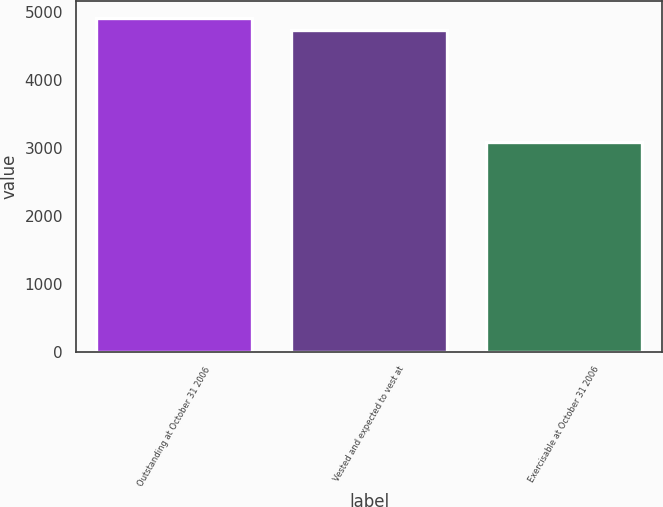Convert chart. <chart><loc_0><loc_0><loc_500><loc_500><bar_chart><fcel>Outstanding at October 31 2006<fcel>Vested and expected to vest at<fcel>Exercisable at October 31 2006<nl><fcel>4920<fcel>4742<fcel>3081<nl></chart> 